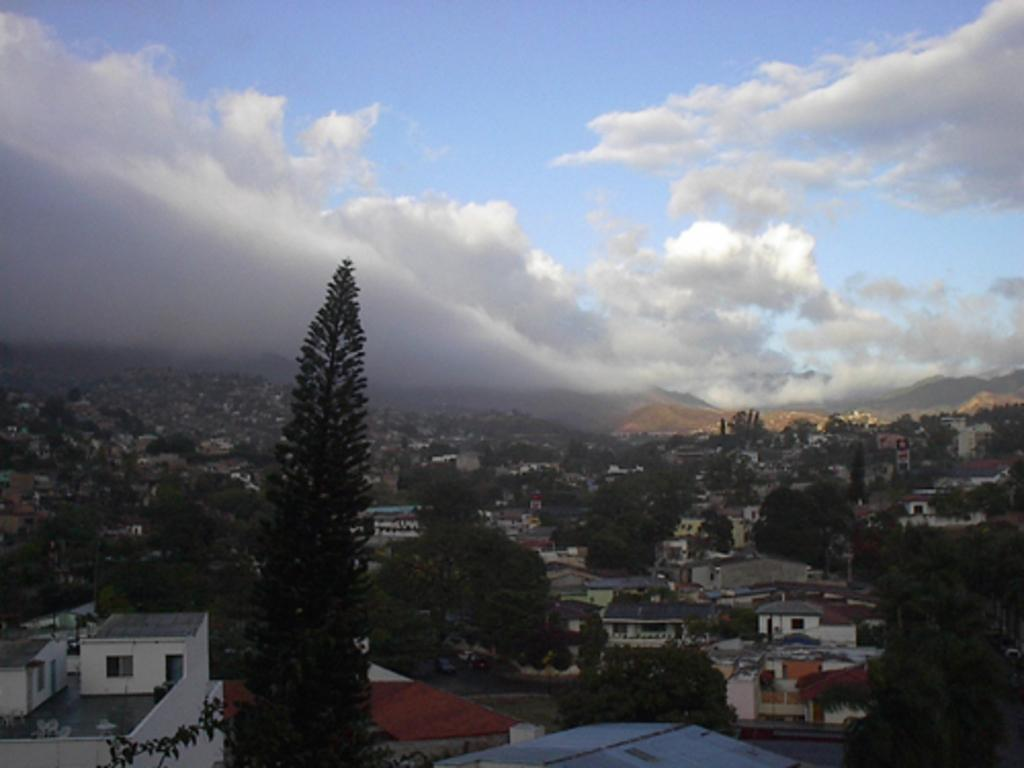What type of view is shown in the image? The image is an aerial view of a city. What natural elements can be seen in the image? There are trees in the image. What man-made structures are visible in the image? There are buildings in the image. What geographical features can be observed in the image? There are hills in the image. How would you describe the weather based on the image? The sky is cloudy in the image. Can you tell me the name of the flower that is being held by the person in the image? There is no person present in the image, and therefore no flower being held. 